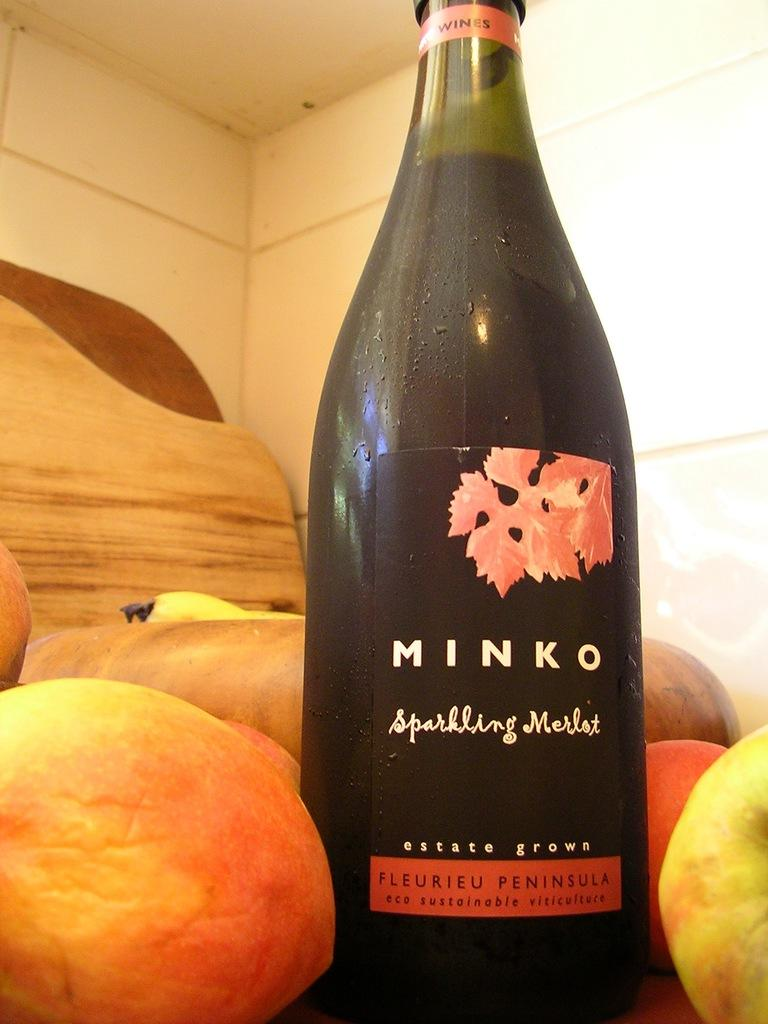What is the main object in the image? There is a wine bottle with a label in the image. What else can be seen on the table in the image? There are fruits on the table in the image. What can be seen in the background of the image? There is a wall visible in the background of the image. What type of stitch is being used to sew the label on the wine bottle in the image? There is no stitching or sewing involved in the label on the wine bottle in the image; it is simply a label attached to the bottle. Can you see a tank in the image? There is no tank present in the image. 